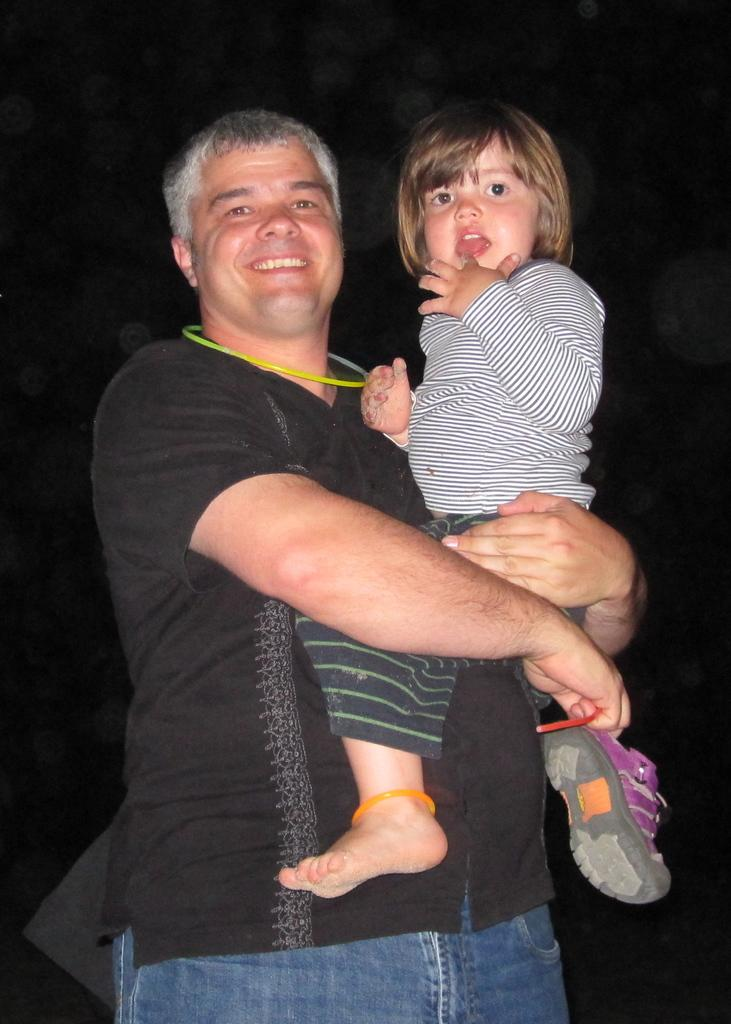Who or what is present in the image? There is a person in the image. What is the person doing in the image? The person is holding a baby with his hands. Where is the hen in the image? There is no hen present in the image. What is the person trying to stop in the image? The image does not show any indication of the person trying to stop something. 